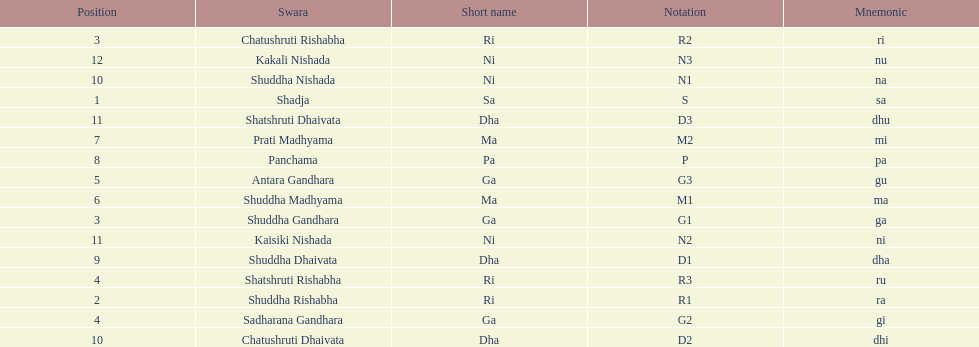List each pair of swaras that share the same position. Chatushruti Rishabha, Shuddha Gandhara, Shatshruti Rishabha, Sadharana Gandhara, Chatushruti Dhaivata, Shuddha Nishada, Shatshruti Dhaivata, Kaisiki Nishada. 